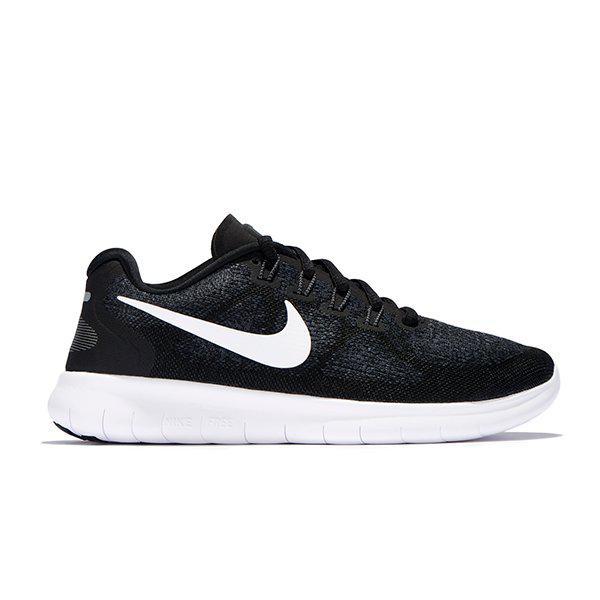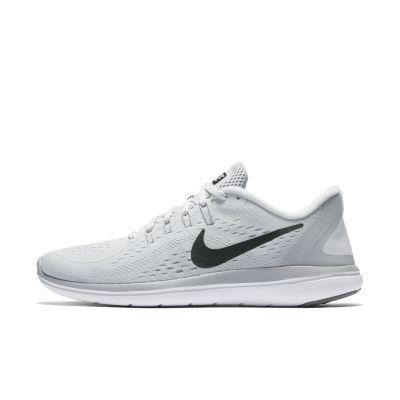The first image is the image on the left, the second image is the image on the right. Given the left and right images, does the statement "There are exactly two shoes shown in one of the images." hold true? Answer yes or no. No. 